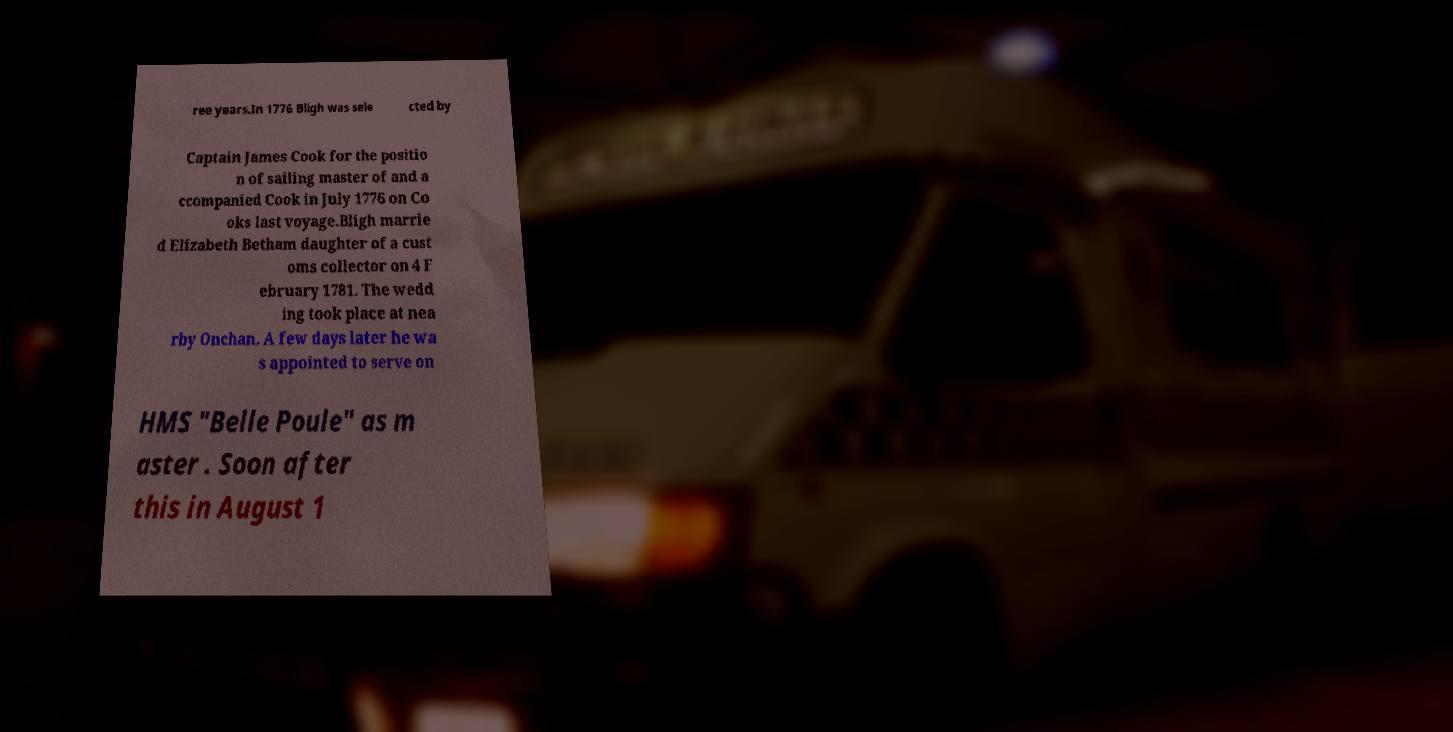Can you accurately transcribe the text from the provided image for me? ree years.In 1776 Bligh was sele cted by Captain James Cook for the positio n of sailing master of and a ccompanied Cook in July 1776 on Co oks last voyage.Bligh marrie d Elizabeth Betham daughter of a cust oms collector on 4 F ebruary 1781. The wedd ing took place at nea rby Onchan. A few days later he wa s appointed to serve on HMS "Belle Poule" as m aster . Soon after this in August 1 